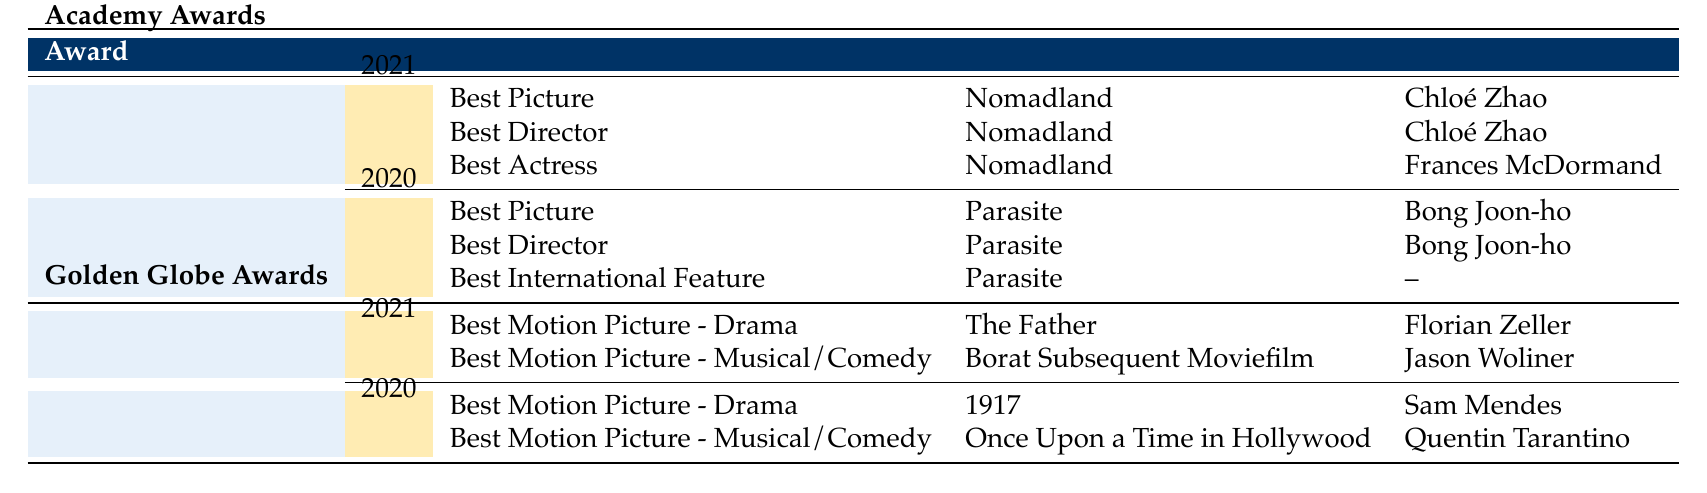What film won the Best Picture at the Academy Awards in 2021? The table shows that "Nomadland" won the Best Picture award at the Academy Awards in 2021.
Answer: Nomadland Who directed Parasite, the film that won the Best Picture award in 2020 at the Academy Awards? The table specifies that "Parasite" was directed by Bong Joon-ho, who also won Best Director that same year.
Answer: Bong Joon-ho True or False: The film "Borat Subsequent Moviefilm" won the Best Motion Picture - Drama at the Golden Globe Awards in 2021. The table indicates that "Borat Subsequent Moviefilm" was nominated for Best Motion Picture - Musical or Comedy, not Best Motion Picture - Drama. Therefore, the statement is false.
Answer: False What is the total number of awards won by the film Nomadland across all its categories at the Academy Awards in 2021? The table states that "Nomadland" won 3 awards for Best Picture, and it doesn't list any further awards for additional categories, so we can conclude it is 3.
Answer: 3 Which film had the most awards won in the Academy Awards of 2020? The table shows that "Parasite" won 4 awards across its categories at the Academy Awards in 2020, which is more than any other listed film.
Answer: Parasite How many different categories did "Parasite" win at the Academy Awards in 2020? "Parasite" won in three different categories: Best Picture, Best Director, and Best International Feature, as seen in the table.
Answer: 3 What were the categories in which "The Father" competed at the Golden Globe Awards in 2021? The table reveals that "The Father" competed in the Best Motion Picture - Drama category and won 2 awards, which means it entered that specific category only.
Answer: Best Motion Picture - Drama What is the difference in the number of awards won by "Nomadland" and "Parasite" at the Academy Awards? "Nomadland" won 3 awards and "Parasite" won 4 awards. The difference is calculated as 4 - 3 = 1.
Answer: 1 True or False: All the films listed in the 2021 Golden Globe Awards were directed by individuals who were nominated for Best Director at the Academy Awards that year. The table does not provide information about the directors of the Golden Globe nominees in relation to the Academy Awards, making it impossible to confirm whether this statement is true or false.
Answer: Unknown 